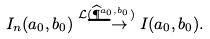Convert formula to latex. <formula><loc_0><loc_0><loc_500><loc_500>I _ { n } ( a _ { 0 } , b _ { 0 } ) \overset { \mathcal { L } ( \widehat { \P } ^ { a _ { 0 } , b _ { 0 } } ) } { \longrightarrow } I ( a _ { 0 } , b _ { 0 } ) .</formula> 